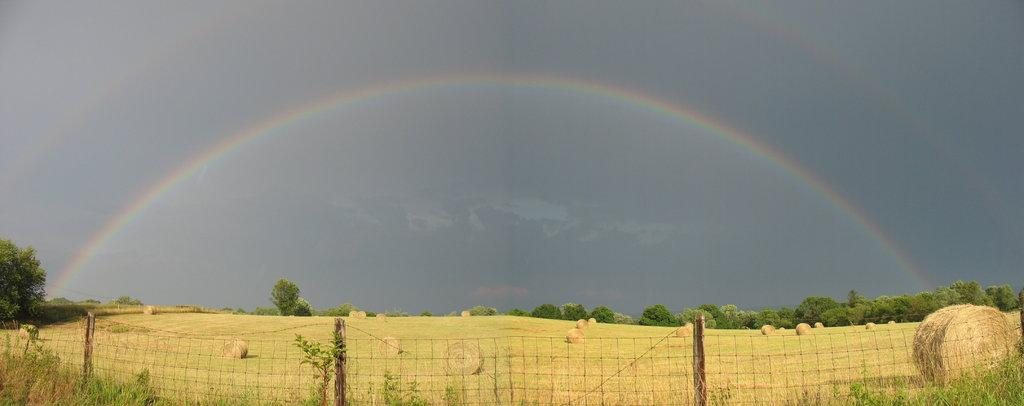What is located at the bottom of the image? There is a fence at the bottom of the image. What is behind the fence? Dry grass rolls and trees are present behind the fence. What can be seen in the background of the image? There is a double rainbow and clouds visible in the sky in the background of the image. What type of rose is growing near the fence in the image? There is no rose present in the image; the vegetation behind the fence consists of dry grass rolls and trees. 